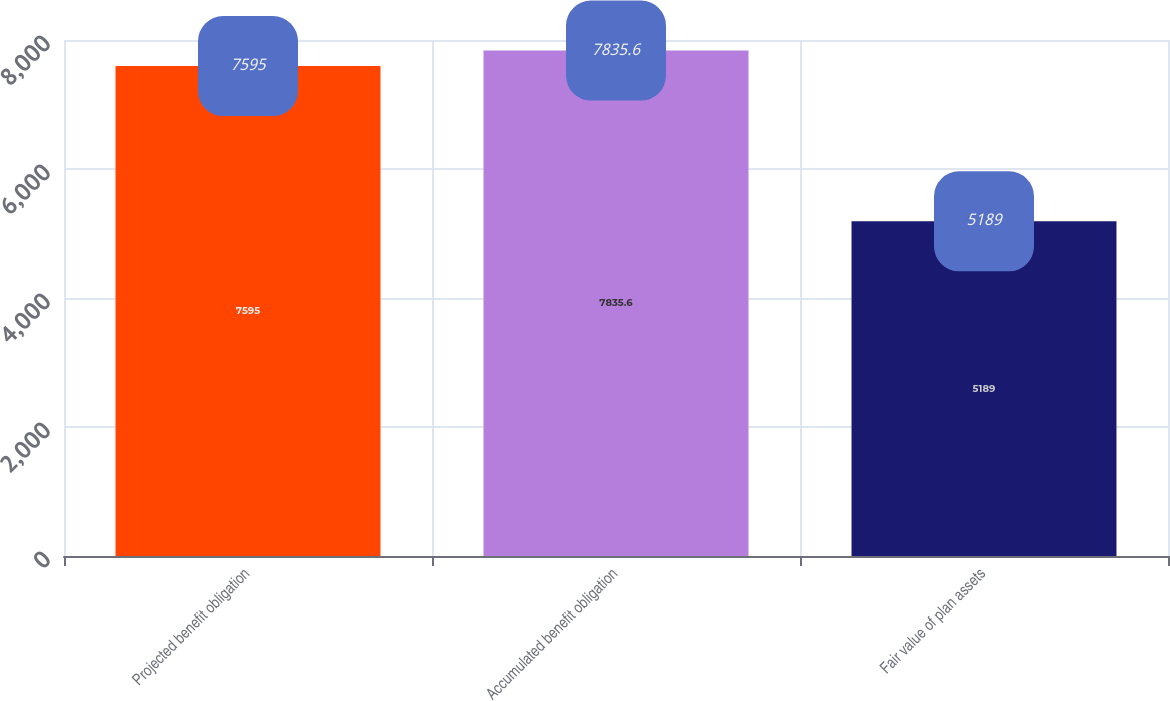<chart> <loc_0><loc_0><loc_500><loc_500><bar_chart><fcel>Projected benefit obligation<fcel>Accumulated benefit obligation<fcel>Fair value of plan assets<nl><fcel>7595<fcel>7835.6<fcel>5189<nl></chart> 